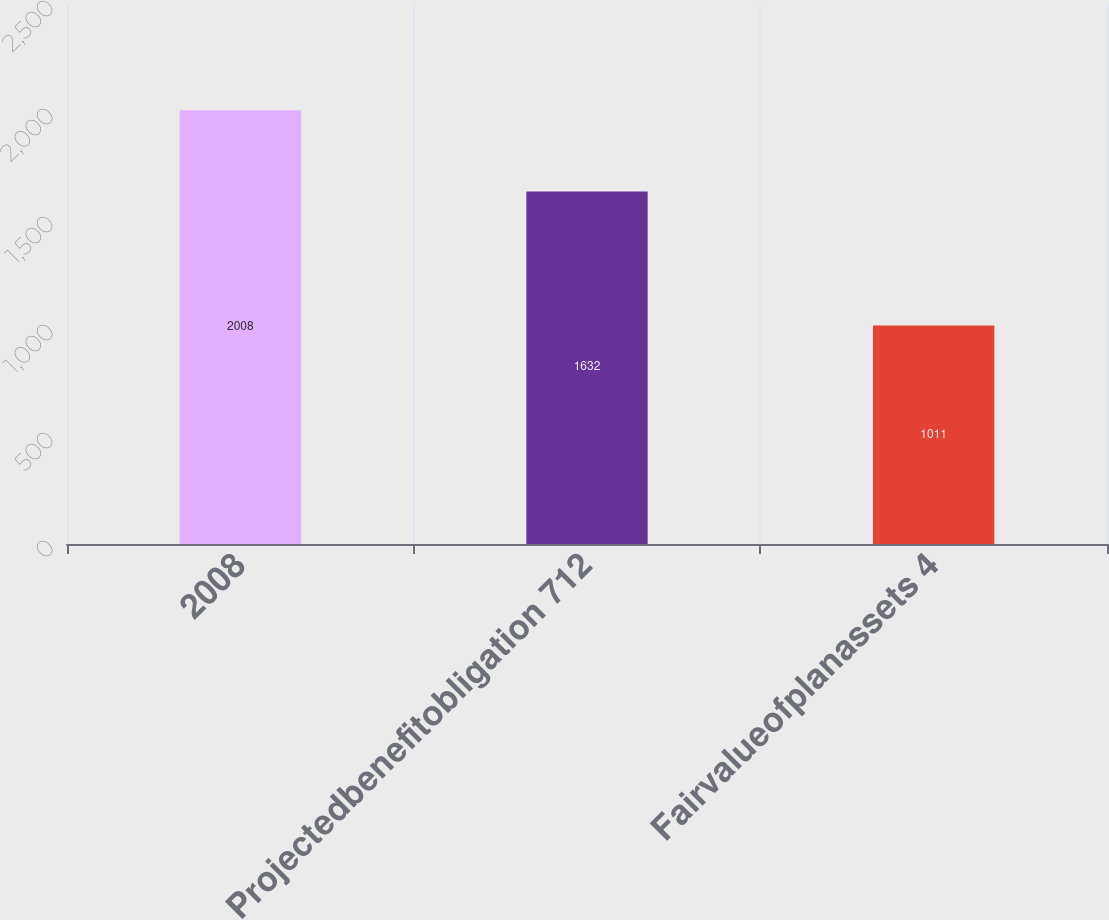<chart> <loc_0><loc_0><loc_500><loc_500><bar_chart><fcel>2008<fcel>Projectedbenefitobligation 712<fcel>Fairvalueofplanassets 4<nl><fcel>2008<fcel>1632<fcel>1011<nl></chart> 